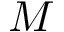<formula> <loc_0><loc_0><loc_500><loc_500>M</formula> 